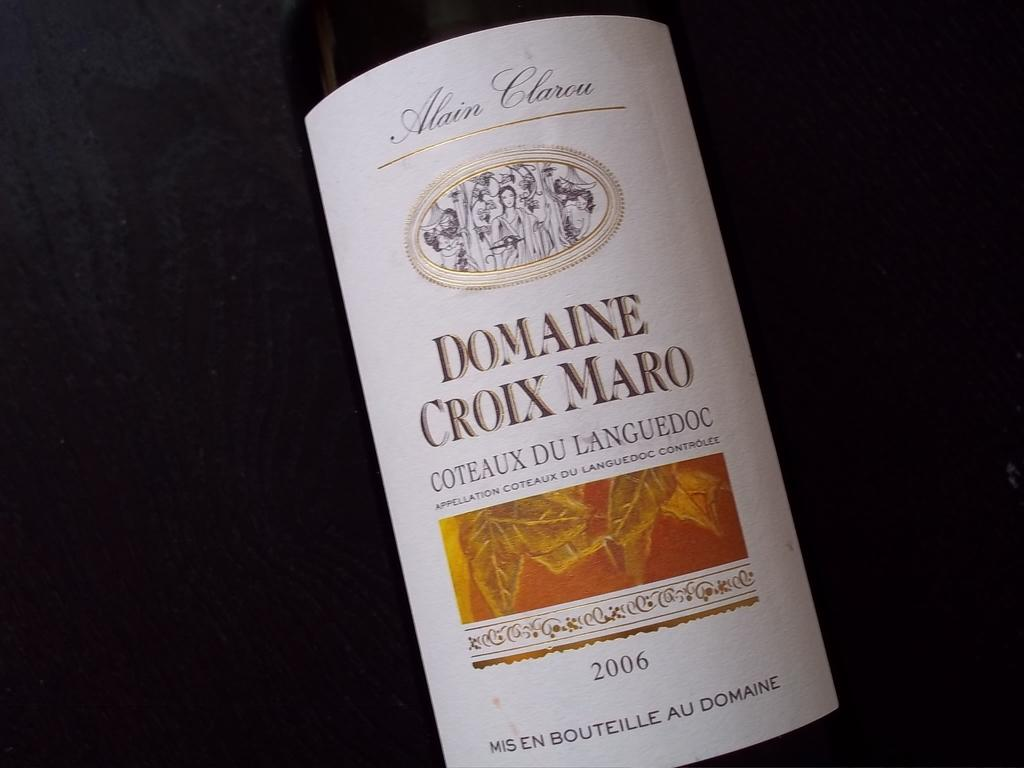<image>
Offer a succinct explanation of the picture presented. A bottle of wine bottle label shows a date of 2006. 